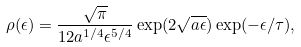<formula> <loc_0><loc_0><loc_500><loc_500>\rho ( \epsilon ) = \frac { \sqrt { \pi } } { 1 2 a ^ { 1 / 4 } \epsilon ^ { 5 / 4 } } \exp ( 2 \sqrt { a \epsilon } ) \exp ( - \epsilon / \tau ) ,</formula> 